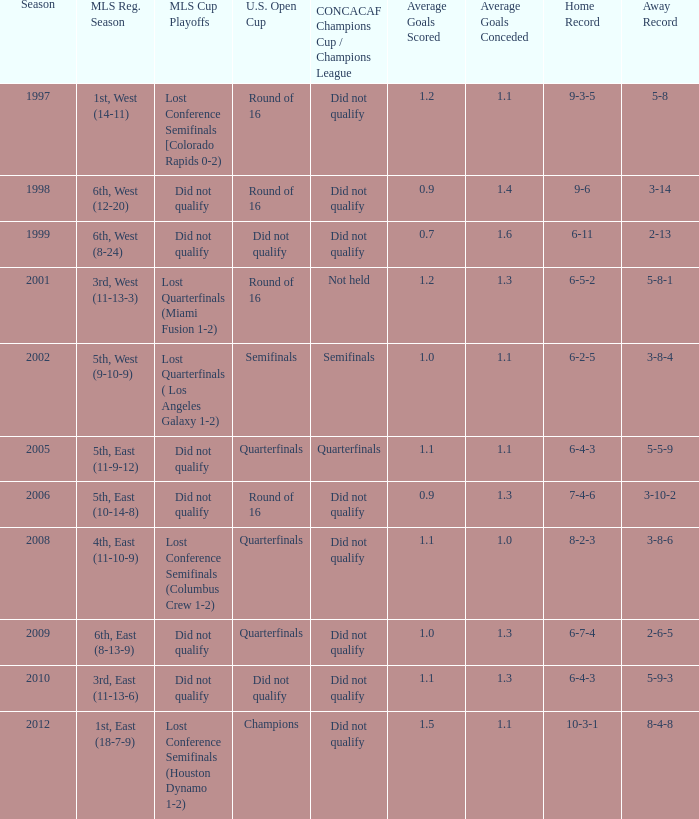When was the initial season? 1997.0. 